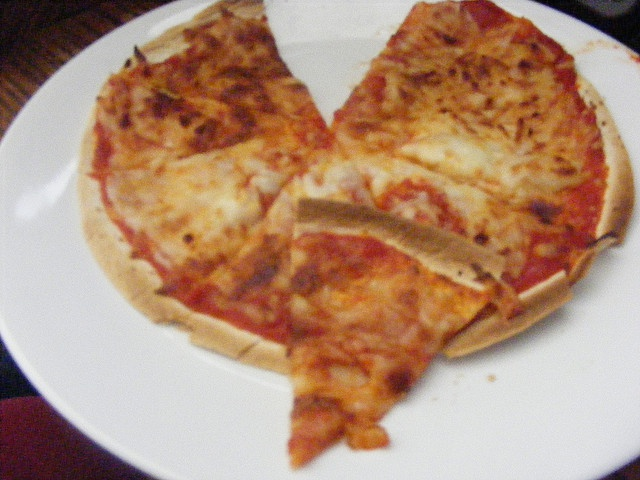Describe the objects in this image and their specific colors. I can see pizza in black, brown, tan, and red tones and pizza in black, brown, red, and tan tones in this image. 